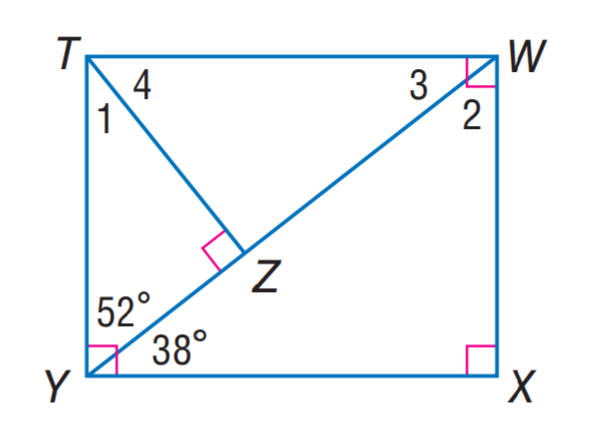Answer the mathemtical geometry problem and directly provide the correct option letter.
Question: Find m \angle 4.
Choices: A: 28 B: 38 C: 52 D: 62 C 